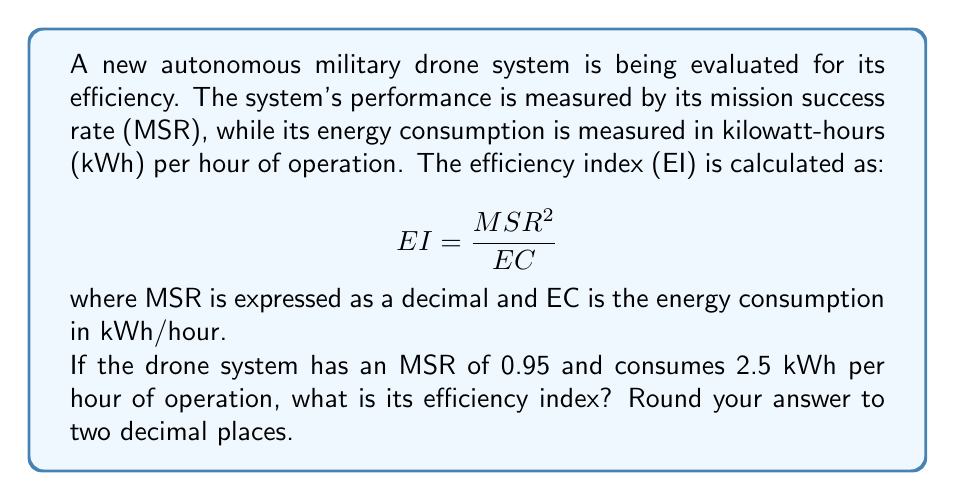Show me your answer to this math problem. To calculate the efficiency index (EI) of the autonomous military drone system, we'll use the given formula and the provided information:

1. Given:
   - Mission Success Rate (MSR) = 0.95
   - Energy Consumption (EC) = 2.5 kWh/hour
   - Formula: $EI = \frac{MSR^2}{EC}$

2. Calculate $MSR^2$:
   $MSR^2 = 0.95^2 = 0.9025$

3. Substitute the values into the formula:
   $EI = \frac{0.9025}{2.5}$

4. Perform the division:
   $EI = 0.361$

5. Round to two decimal places:
   $EI \approx 0.36$

Therefore, the efficiency index of the autonomous military drone system is 0.36.
Answer: 0.36 